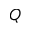Convert formula to latex. <formula><loc_0><loc_0><loc_500><loc_500>Q</formula> 